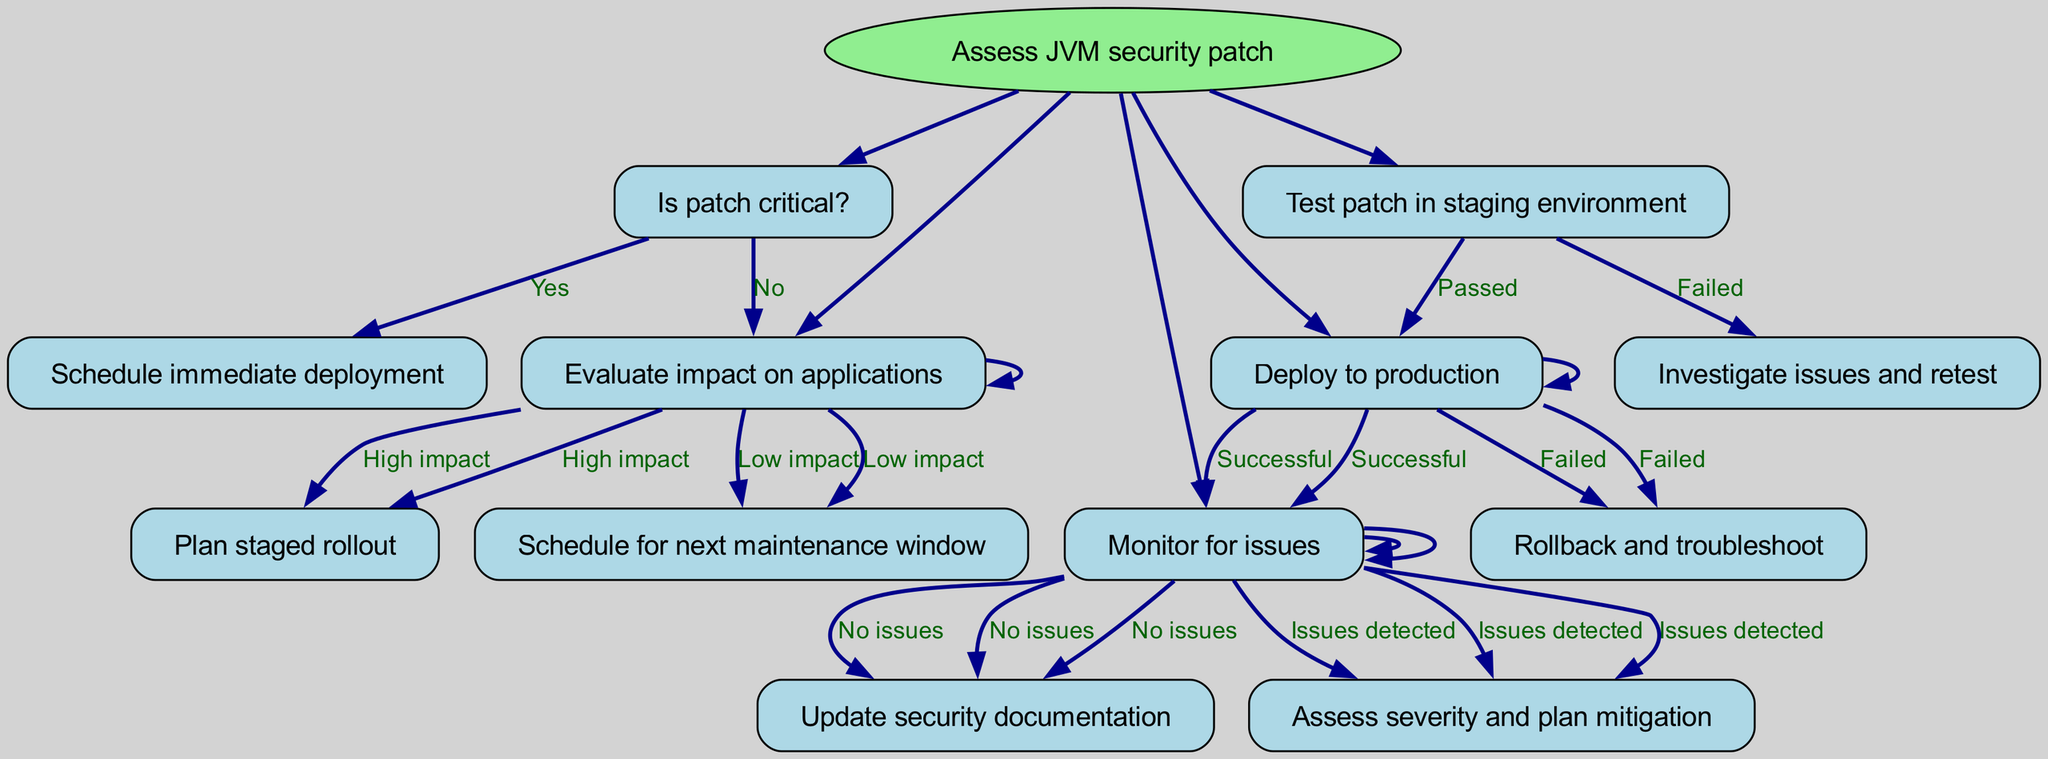What is the root node of the diagram? The root node, which represents the starting point of the decision-making process, is labeled "Assess JVM security patch."
Answer: Assess JVM security patch How many decisions are there in total? There are five decisions presented in the diagram, each representing a different step in the decision tree.
Answer: Five What happens if the patch is critical? If the patch is critical, the next step is to "Schedule immediate deployment," reflecting the urgency of the situation.
Answer: Schedule immediate deployment What node follows "Evaluate impact on applications"? After evaluating the impact on applications, the outcomes are either "Plan staged rollout" for high impact or "Schedule for next maintenance window" for low impact.
Answer: Plan staged rollout or Schedule for next maintenance window What is the outcome if the patch test in the staging environment passes? If the patch test in the staging environment passes, the next action is to "Deploy to production," indicating readiness for implementation.
Answer: Deploy to production What is the next step after deploying to production if successful? After a successful deployment to production, the next step is to "Monitor for issues," which involves overseeing the system for possible problems.
Answer: Monitor for issues How does the diagram categorize the impact of the application evaluation? The impact evaluation categorizes applications into high impact or low impact, which dictates the subsequent steps in patch management.
Answer: High impact or Low impact What are the two outcomes after monitoring for issues? The outcomes after monitoring for issues are "Update security documentation" if no issues are detected or "Assess severity and plan mitigation" if issues are present.
Answer: Update security documentation or Assess severity and plan mitigation What does the diagram suggest if the patch fails in the staging environment? If the patch fails in the staging environment, the diagram suggests to "Investigate issues and retest" before proceeding further in the workflow.
Answer: Investigate issues and retest 